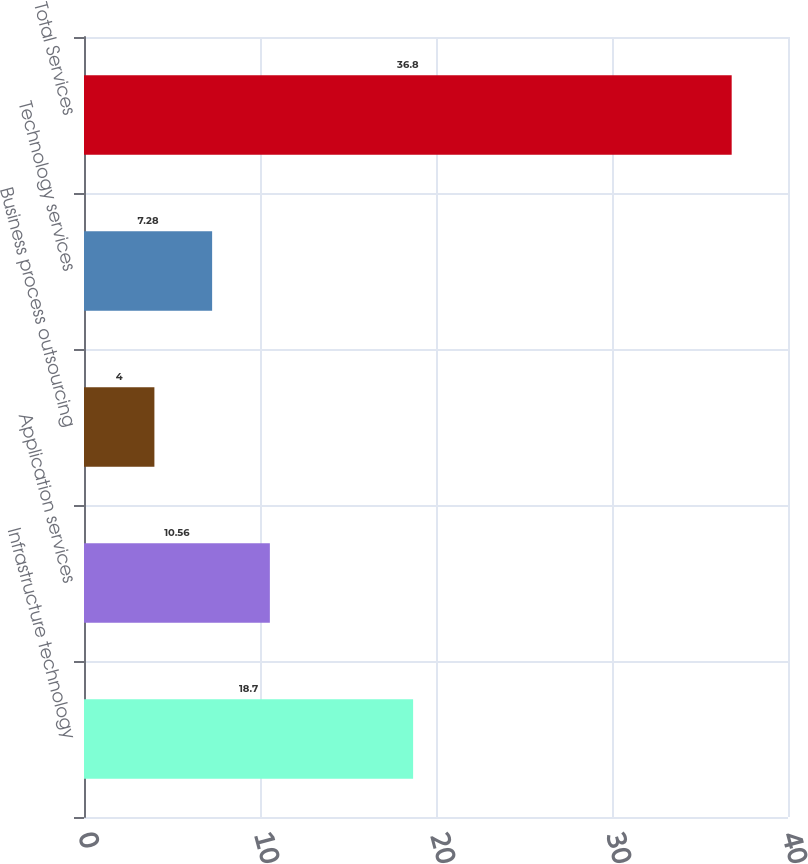Convert chart to OTSL. <chart><loc_0><loc_0><loc_500><loc_500><bar_chart><fcel>Infrastructure technology<fcel>Application services<fcel>Business process outsourcing<fcel>Technology services<fcel>Total Services<nl><fcel>18.7<fcel>10.56<fcel>4<fcel>7.28<fcel>36.8<nl></chart> 